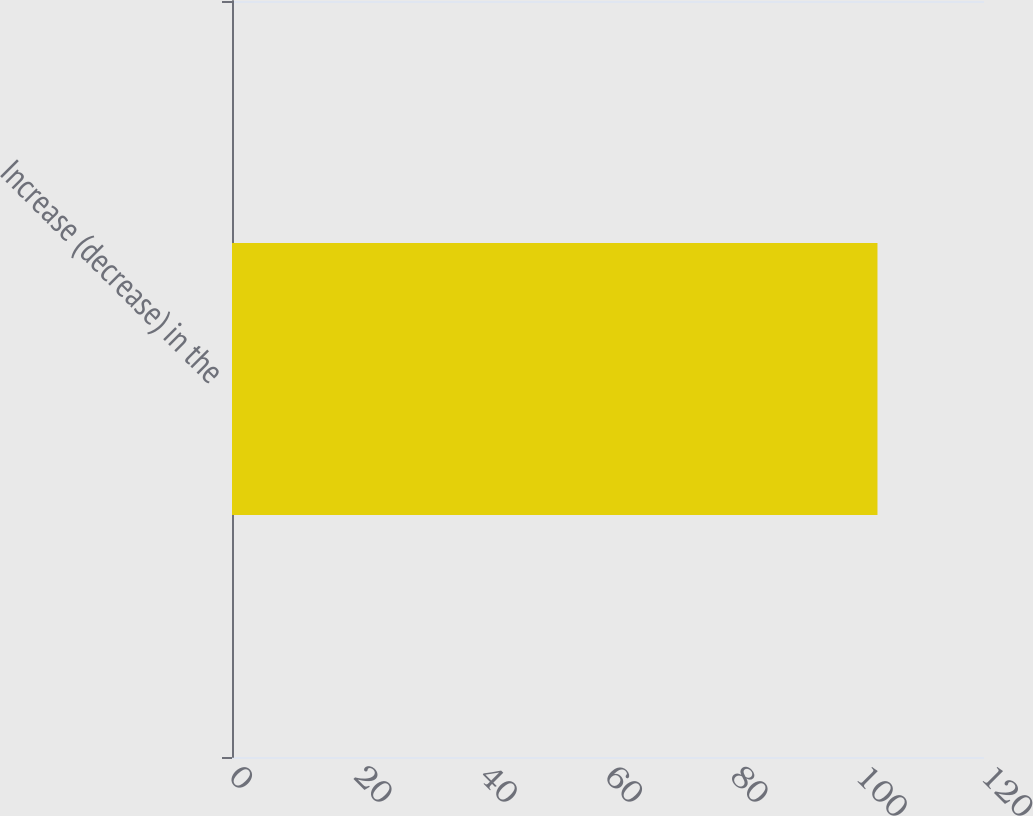Convert chart to OTSL. <chart><loc_0><loc_0><loc_500><loc_500><bar_chart><fcel>Increase (decrease) in the<nl><fcel>103<nl></chart> 